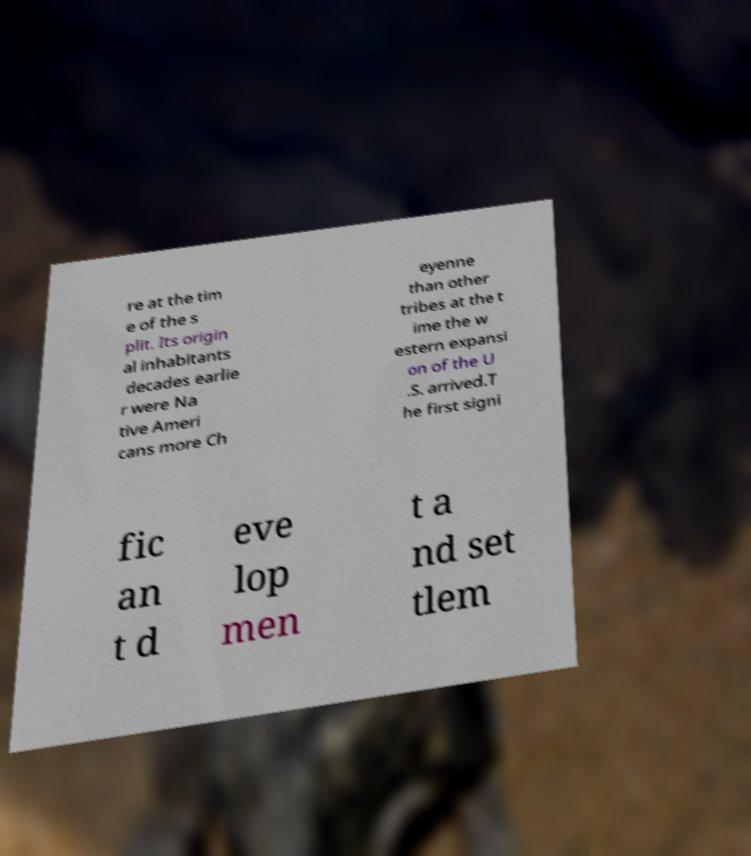Could you extract and type out the text from this image? re at the tim e of the s plit. Its origin al inhabitants decades earlie r were Na tive Ameri cans more Ch eyenne than other tribes at the t ime the w estern expansi on of the U .S. arrived.T he first signi fic an t d eve lop men t a nd set tlem 